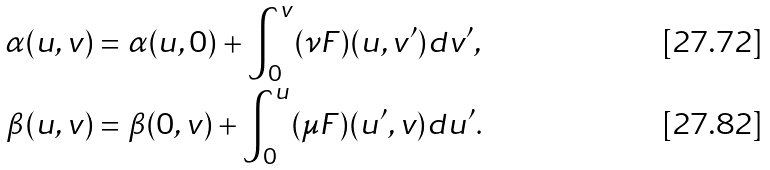<formula> <loc_0><loc_0><loc_500><loc_500>\alpha ( u , v ) & = \alpha ( u , 0 ) + \int _ { 0 } ^ { v } ( \nu F ) ( u , v ^ { \prime } ) d v ^ { \prime } , \\ \beta ( u , v ) & = \beta ( 0 , v ) + \int _ { 0 } ^ { u } ( \mu F ) ( u ^ { \prime } , v ) d u ^ { \prime } .</formula> 